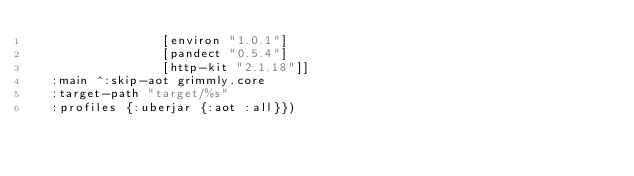<code> <loc_0><loc_0><loc_500><loc_500><_Clojure_>                 [environ "1.0.1"]
                 [pandect "0.5.4"]
                 [http-kit "2.1.18"]]
  :main ^:skip-aot grimmly.core
  :target-path "target/%s"
  :profiles {:uberjar {:aot :all}})
</code> 